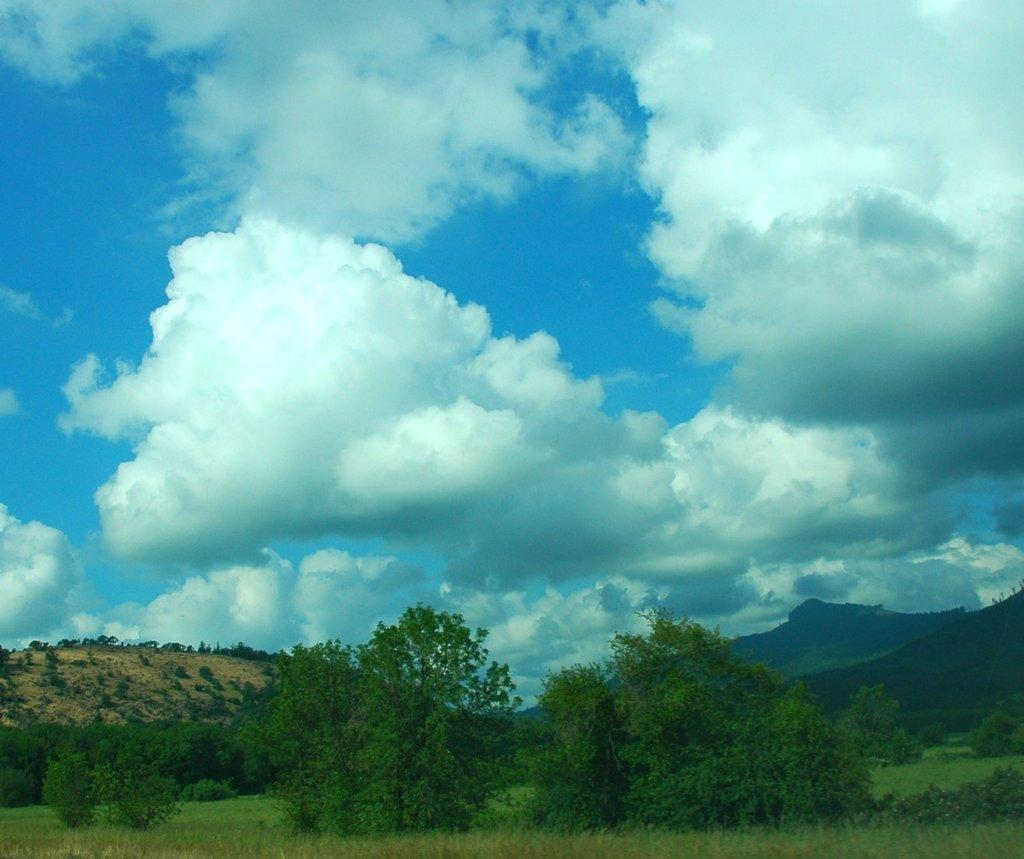What type of vegetation can be seen in the image? There are trees and plants in the image. What is the terrain like in the image? There is a hill in the image. What is the color of the sky in the image? The sky is blue and cloudy in the image. What type of ground cover is present in the image? There is grass on the ground in the image. Where is the alley located in the image? There is no alley present in the image. How many pins are visible in the image? There are no pins visible in the image. 